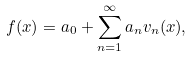<formula> <loc_0><loc_0><loc_500><loc_500>f ( x ) = a _ { 0 } + \sum _ { n = 1 } ^ { \infty } a _ { n } v _ { n } ( x ) ,</formula> 